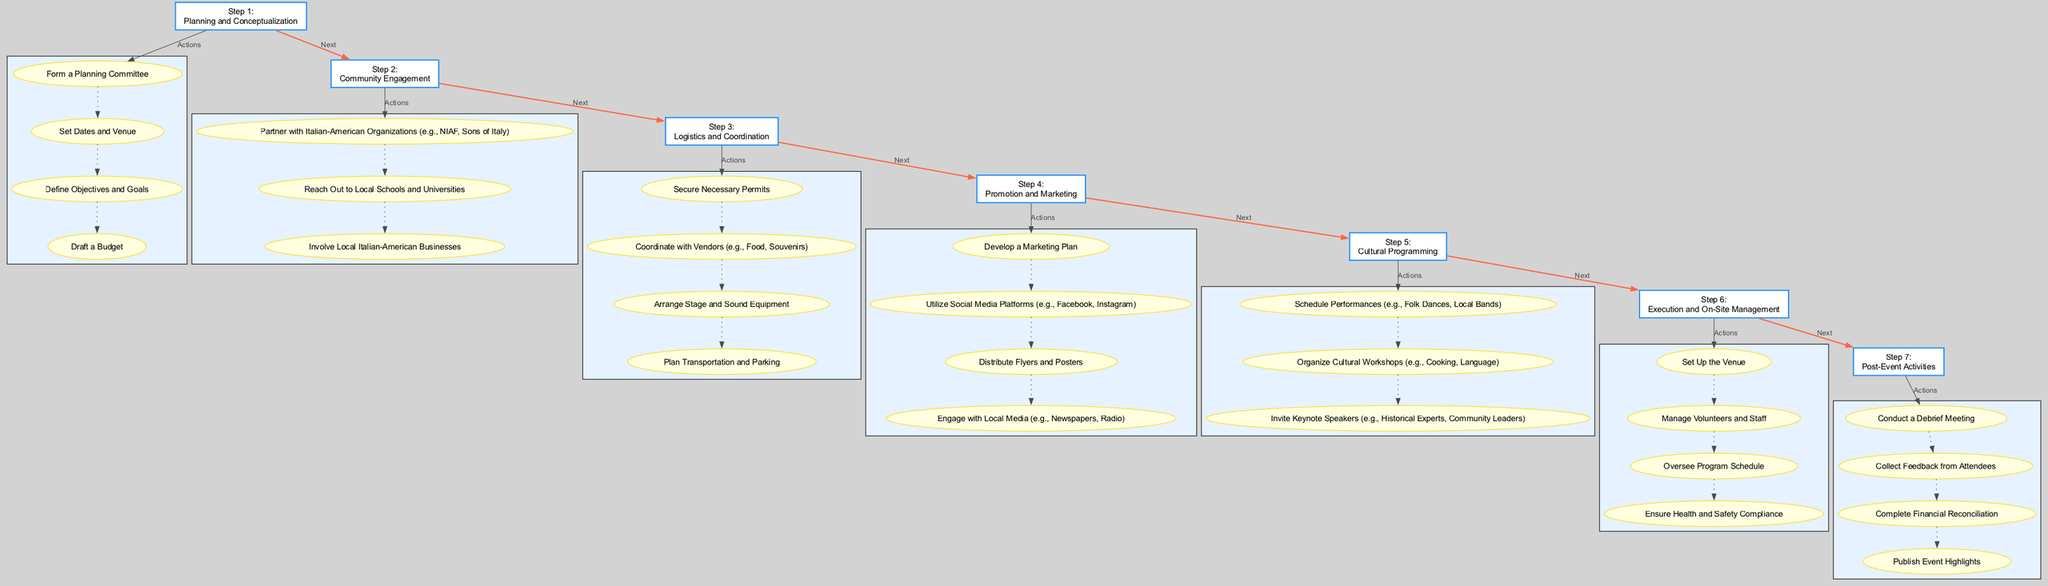What is the title of Step 1? The title of Step 1 is directly mentioned in the diagram as "Planning and Conceptualization". This can be found in the first rectangular node labeled step 1.
Answer: Planning and Conceptualization How many actions are listed under Step 3? In Step 3, there are four actions outlined within the subgraph, which are connected with edges labeled "Actions". Counting these actions will confirm their number.
Answer: 4 Which step comes before Cultural Programming? Cultural Programming is listed as Step 5 in the diagram, and by following the flow from the previous steps, Step 4 is directly connected to it. Thus, Step 4 is before it.
Answer: Step 4 What is the main focus of Step 6? Step 6 is titled "Execution and On-Site Management", which indicates its main focus is on managing activities during the festival event.
Answer: Execution and On-Site Management Which action is the first listed under Step 2? The first action listed under Step 2 ("Community Engagement") is "Partner with Italian-American Organizations". This is identifiable as the top action in the corresponding subgraph.
Answer: Partner with Italian-American Organizations How many steps are there in total in the diagram? The diagram includes a total of seven distinct steps, which can be counted from the rectangular nodes labeled from Step 1 to Step 7.
Answer: 7 What connects Step 5 to Step 6? Step 5 is connected to Step 6 by an edge labeled "Next". This directional arrow illustrates the flow from the end of one process to the beginning of the next.
Answer: Next What types of organizations should be partnered with in Step 2? Step 2 emphasizes partnering with "Italian-American Organizations" and specifically mentions examples such as NIAF and Sons of Italy, highlighting the focus on community connection.
Answer: Italian-American Organizations Which action under Step 4 involves media engagement? The action in Step 4 that involves media engagement is "Engage with Local Media", which targets newspapers and radio for promotion. This is explicitly stated among the listed actions.
Answer: Engage with Local Media 